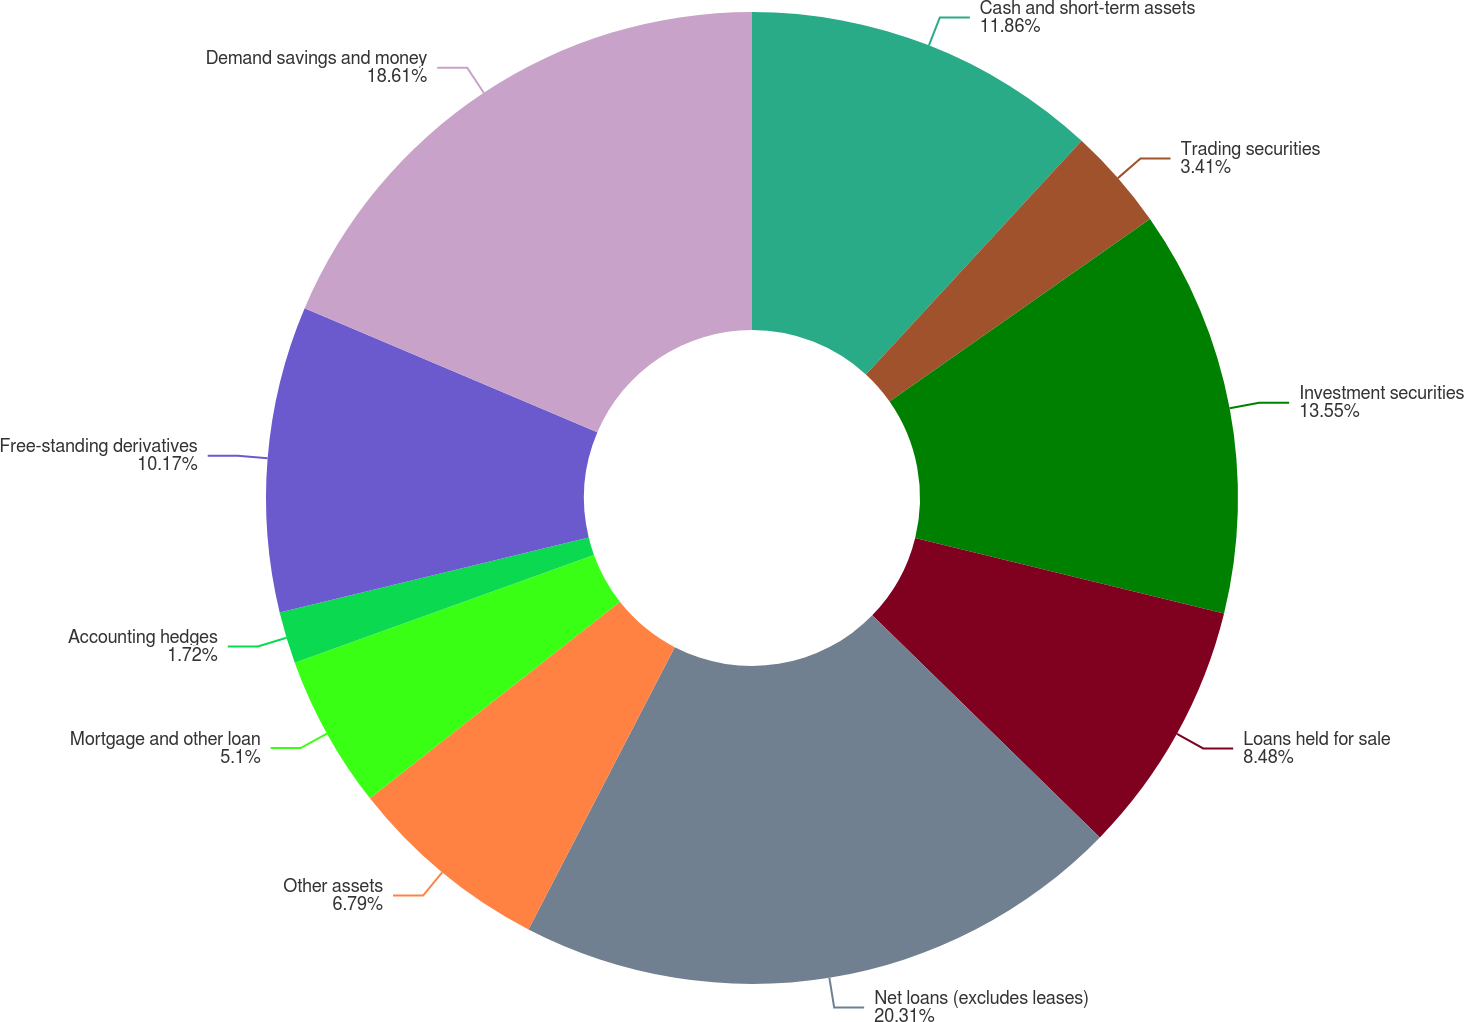<chart> <loc_0><loc_0><loc_500><loc_500><pie_chart><fcel>Cash and short-term assets<fcel>Trading securities<fcel>Investment securities<fcel>Loans held for sale<fcel>Net loans (excludes leases)<fcel>Other assets<fcel>Mortgage and other loan<fcel>Accounting hedges<fcel>Free-standing derivatives<fcel>Demand savings and money<nl><fcel>11.86%<fcel>3.41%<fcel>13.55%<fcel>8.48%<fcel>20.3%<fcel>6.79%<fcel>5.1%<fcel>1.72%<fcel>10.17%<fcel>18.61%<nl></chart> 